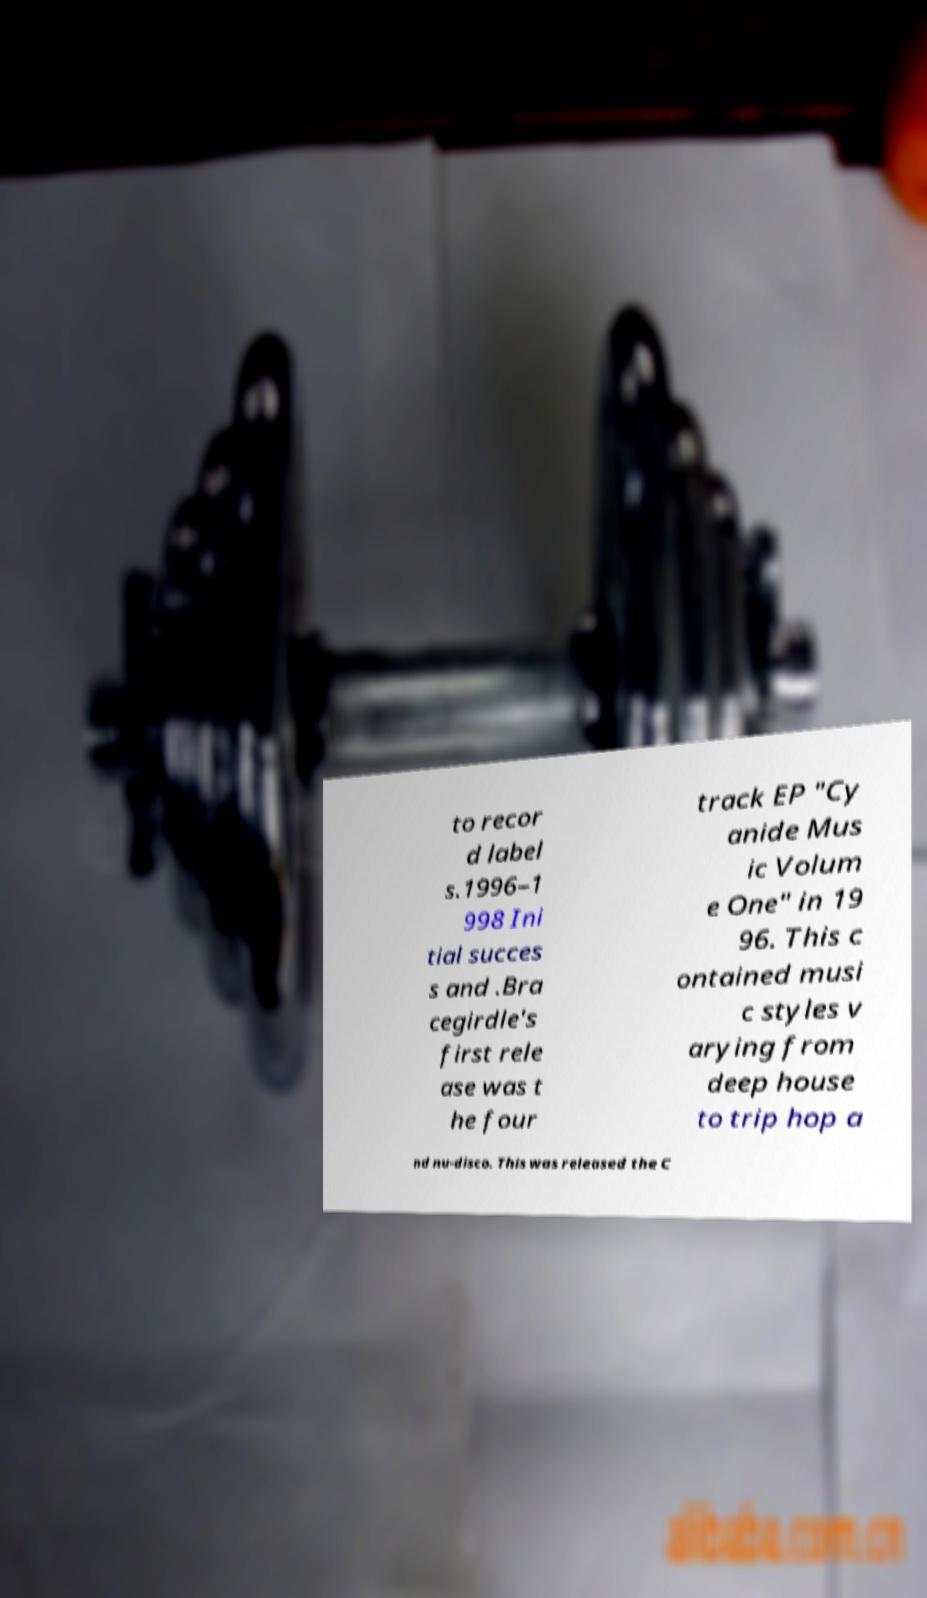I need the written content from this picture converted into text. Can you do that? to recor d label s.1996–1 998 Ini tial succes s and .Bra cegirdle's first rele ase was t he four track EP "Cy anide Mus ic Volum e One" in 19 96. This c ontained musi c styles v arying from deep house to trip hop a nd nu-disco. This was released the C 